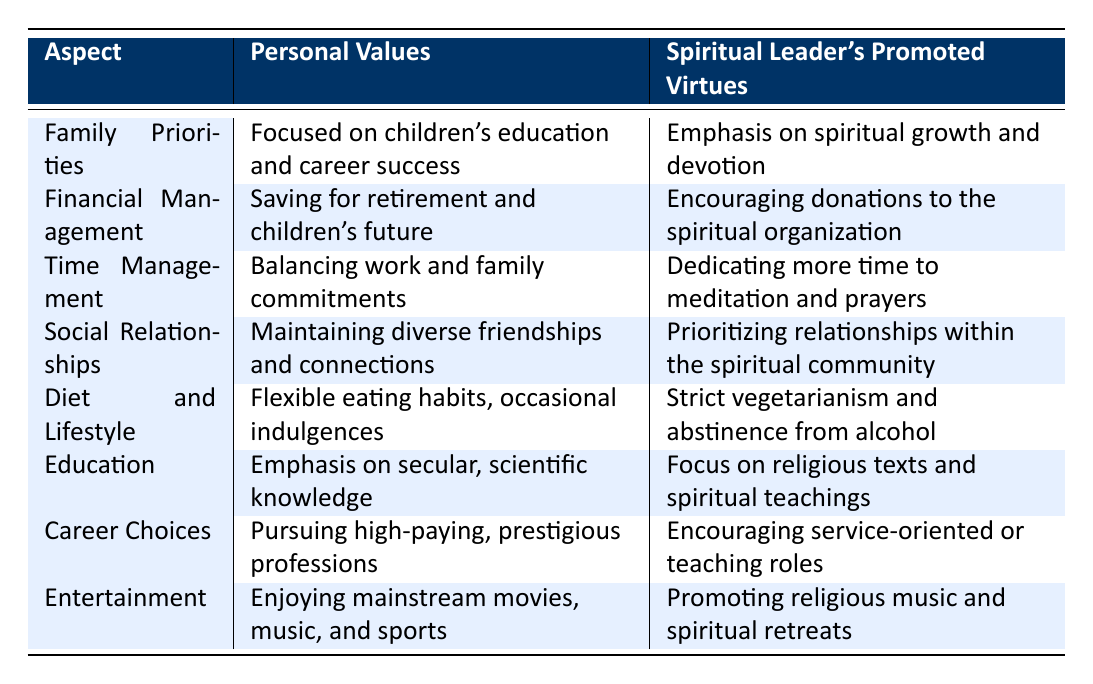What is the primary focus of personal values regarding family? The table states that personal values are "Focused on children's education and career success," which highlights an emphasis on ensuring the well-being and future of children in terms of education and professional achievements.
Answer: Focused on children's education and career success Does the spiritual leader promote financial management that prioritizes personal savings? According to the table, the spiritual leader's stance on financial management involves "Encouraging donations to the spiritual organization," which indicates that personal savings are not prioritized over this spiritual encouragement.
Answer: No Which aspect of time management is emphasized by the spiritual leader? The table presents that the spiritual leader emphasizes "Dedicating more time to meditation and prayers," suggesting a focus on spiritual practices rather than balancing work and personal commitments.
Answer: Dedicating more time to meditation and prayers Are the personal values more focused on diet flexibility than the spiritual leader's values? Personal values state "Flexible eating habits, occasional indulgences," while the spiritual leader’s values are "Strict vegetarianism and abstinence from alcohol," showing that personal values allow for more flexibility in dietary choices.
Answer: Yes What themes are prioritized in social relationships according to the table? The table indicates that personal values focus on "Maintaining diverse friendships and connections," whereas the spiritual leader’s values prioritize "relationships within the spiritual community," emphasizing unity within that framework. To identify trends between both aspects, one notes the contrasting approaches to social relationships.
Answer: Maintaining diverse friendships and connections vs. prioritizing relationships within the spiritual community What is the difference in educational focus between personal beliefs and the spiritual leader's teachings? The table shows that personal values emphasize "secular, scientific knowledge," while the spiritual leader focuses on "religious texts and spiritual teachings." This illustrates a distinction where personal beliefs lean towards a broader educational perspective, contrasting with the spiritual leader's more niche focus.
Answer: Secular, scientific knowledge vs. religious texts and spiritual teachings Does the table suggest a conflict between personal entertainment choices and those promoted by the spiritual leader? The personal values point out "Enjoying mainstream movies, music, and sports," whereas the spiritual leader promotes "religious music and spiritual retreats," indicating a difference in entertainment choices that could lead to conflict in values.
Answer: Yes How might one characterize the differences in career choices based on the table? The table indicates that personal values are centered around "Pursuing high-paying, prestigious professions," in contrast to the spiritual leader's preferences for "service-oriented or teaching roles," highlighting a significant divergence in career priorities between personal and spiritual perspectives.
Answer: Pursuing high-paying professions vs. service-oriented roles 